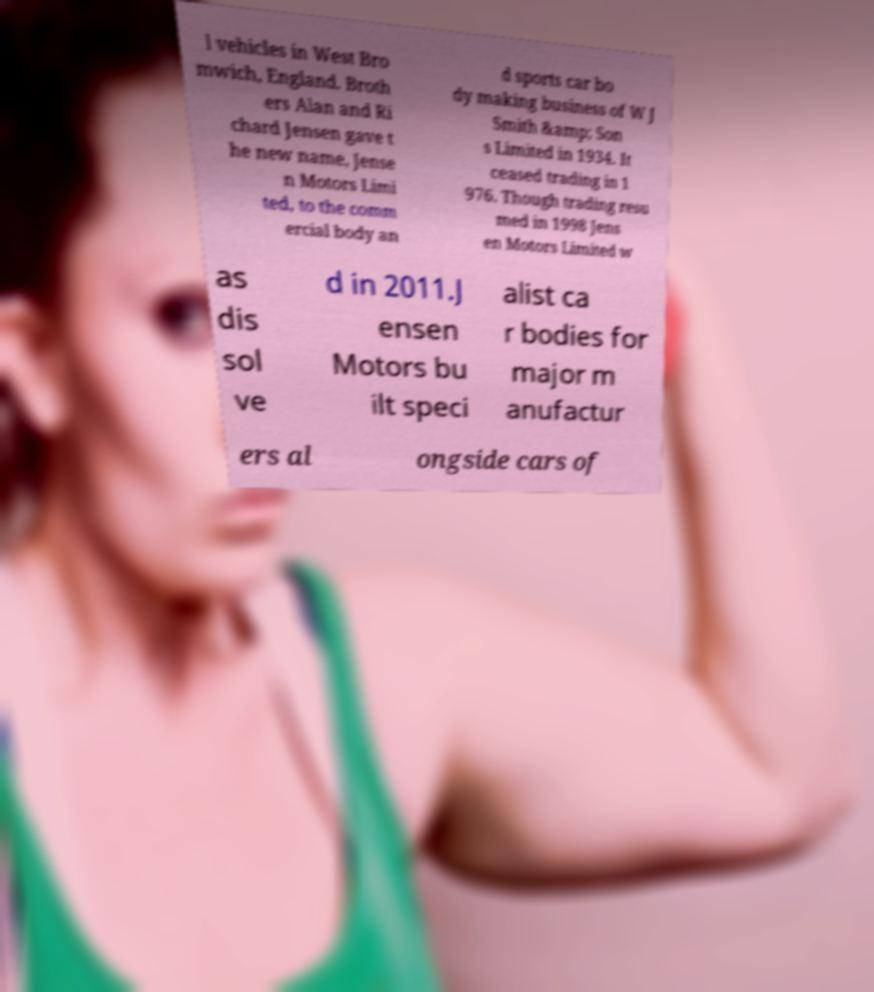Please read and relay the text visible in this image. What does it say? l vehicles in West Bro mwich, England. Broth ers Alan and Ri chard Jensen gave t he new name, Jense n Motors Limi ted, to the comm ercial body an d sports car bo dy making business of W J Smith &amp; Son s Limited in 1934. It ceased trading in 1 976. Though trading resu med in 1998 Jens en Motors Limited w as dis sol ve d in 2011.J ensen Motors bu ilt speci alist ca r bodies for major m anufactur ers al ongside cars of 